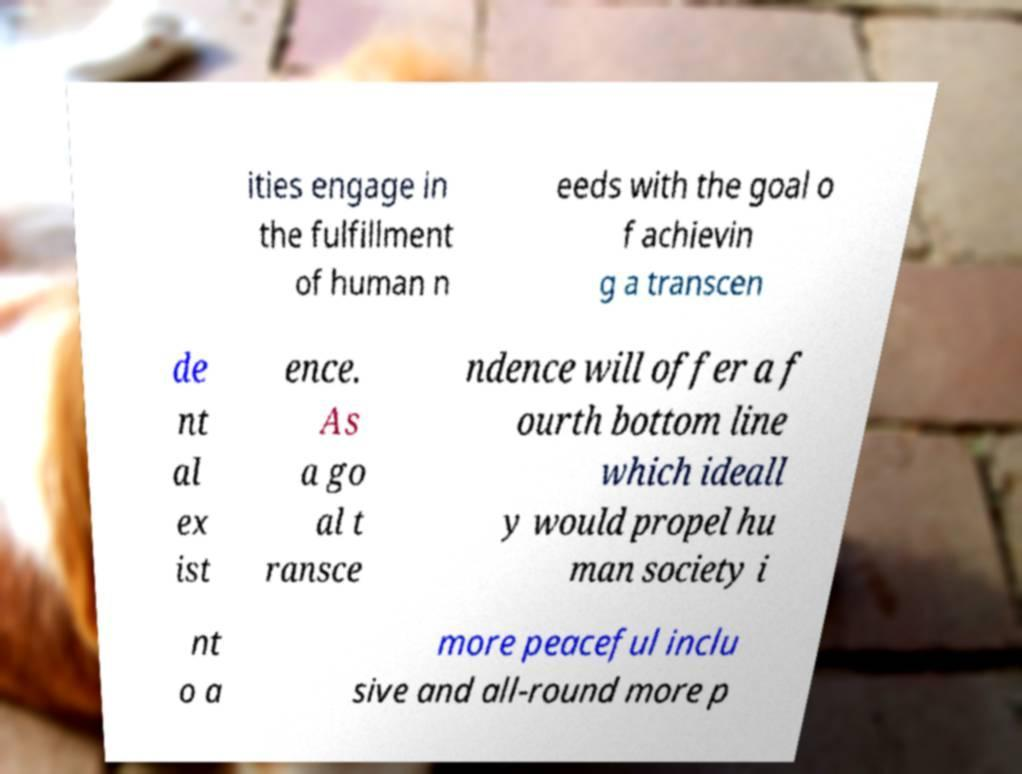For documentation purposes, I need the text within this image transcribed. Could you provide that? ities engage in the fulfillment of human n eeds with the goal o f achievin g a transcen de nt al ex ist ence. As a go al t ransce ndence will offer a f ourth bottom line which ideall y would propel hu man society i nt o a more peaceful inclu sive and all-round more p 